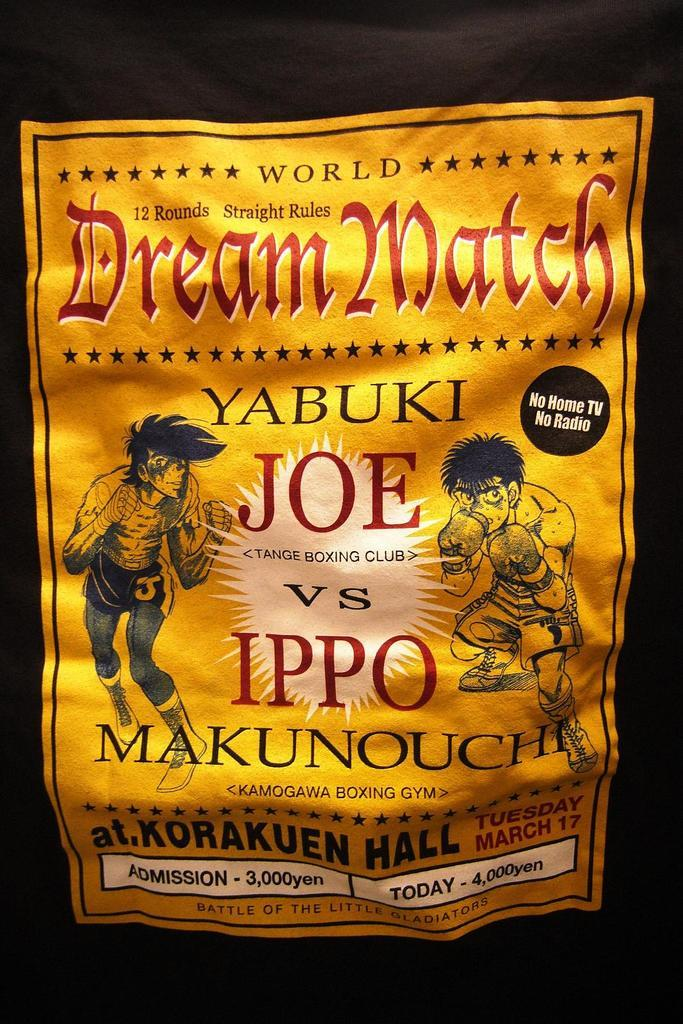<image>
Render a clear and concise summary of the photo. A flyer advertising the Dream Match fight between Yabuki Joe and Ippo Makunouchi. 